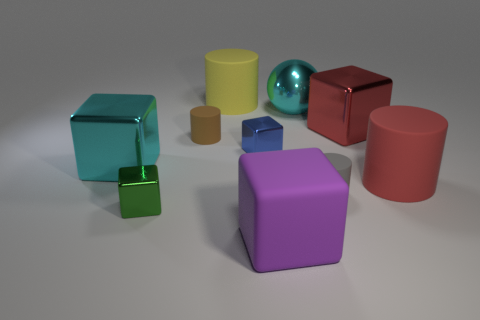Subtract all big blocks. How many blocks are left? 2 Subtract all brown cylinders. How many cylinders are left? 3 Subtract 1 cylinders. How many cylinders are left? 3 Subtract all cyan blocks. Subtract all red spheres. How many blocks are left? 4 Subtract all yellow cubes. How many brown cylinders are left? 1 Subtract all tiny gray rubber cylinders. Subtract all green things. How many objects are left? 8 Add 5 big blocks. How many big blocks are left? 8 Add 4 green things. How many green things exist? 5 Subtract 0 red balls. How many objects are left? 10 Subtract all spheres. How many objects are left? 9 